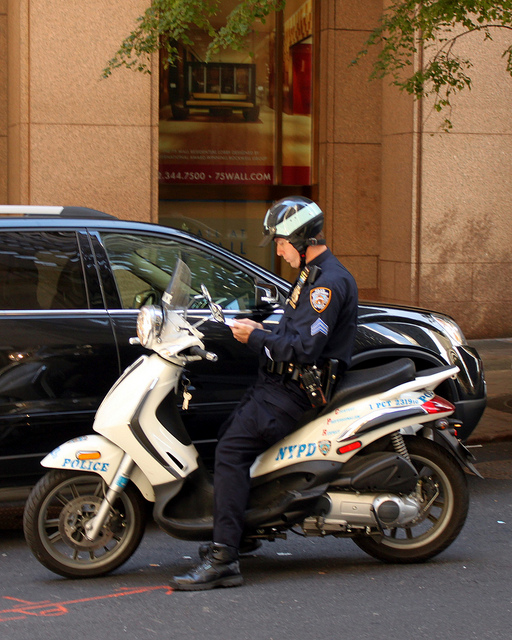<image>Is the motorcycle static or kinetic? I don't know if the motorcycle is static or kinetic. But it can be seen as static. What color is the car in the background? I am not certain. The color of the car in the background might be black. Is the motorcycle static or kinetic? I don't know if the motorcycle is static or kinetic. What color is the car in the background? The car in the background is black. 